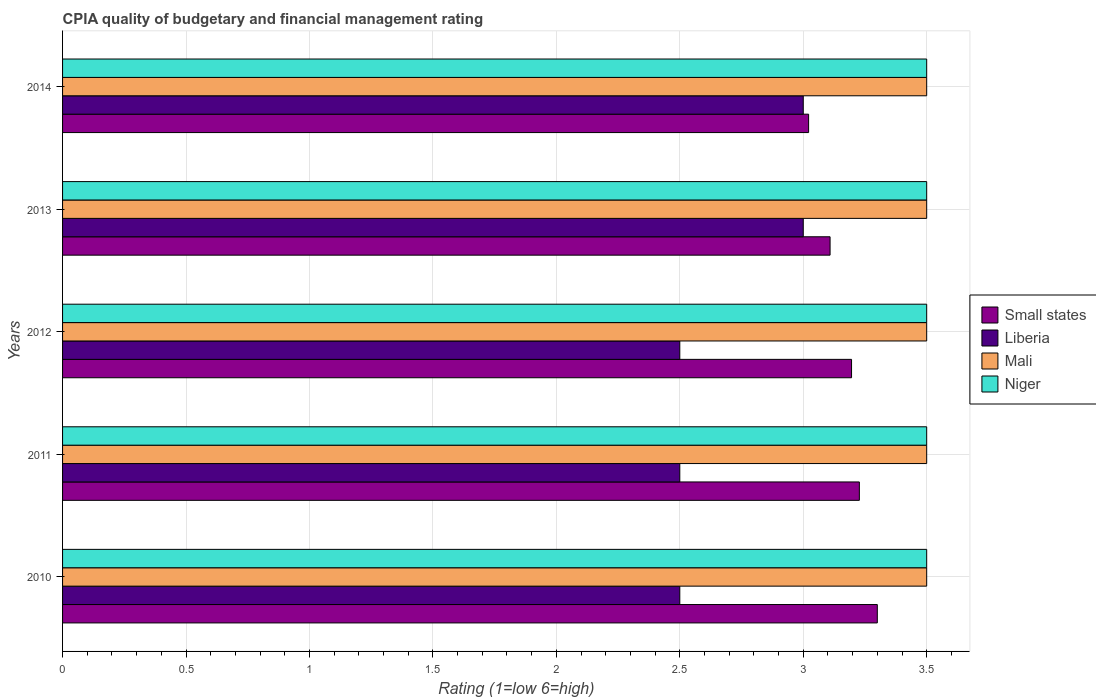Are the number of bars on each tick of the Y-axis equal?
Offer a very short reply. Yes. How many bars are there on the 2nd tick from the top?
Give a very brief answer. 4. How many bars are there on the 1st tick from the bottom?
Your answer should be very brief. 4. What is the label of the 4th group of bars from the top?
Your response must be concise. 2011. Across all years, what is the minimum CPIA rating in Mali?
Ensure brevity in your answer.  3.5. In which year was the CPIA rating in Niger minimum?
Provide a short and direct response. 2010. What is the total CPIA rating in Mali in the graph?
Keep it short and to the point. 17.5. In how many years, is the CPIA rating in Niger greater than 0.4 ?
Give a very brief answer. 5. What is the ratio of the CPIA rating in Mali in 2011 to that in 2012?
Ensure brevity in your answer.  1. Is the CPIA rating in Mali in 2010 less than that in 2012?
Provide a short and direct response. No. Is the difference between the CPIA rating in Niger in 2011 and 2014 greater than the difference between the CPIA rating in Mali in 2011 and 2014?
Offer a terse response. No. What is the difference between the highest and the second highest CPIA rating in Small states?
Make the answer very short. 0.07. Is the sum of the CPIA rating in Niger in 2011 and 2014 greater than the maximum CPIA rating in Small states across all years?
Give a very brief answer. Yes. What does the 3rd bar from the top in 2010 represents?
Provide a short and direct response. Liberia. What does the 4th bar from the bottom in 2012 represents?
Provide a succinct answer. Niger. Are all the bars in the graph horizontal?
Your response must be concise. Yes. How many years are there in the graph?
Provide a short and direct response. 5. Does the graph contain any zero values?
Ensure brevity in your answer.  No. How many legend labels are there?
Give a very brief answer. 4. What is the title of the graph?
Offer a terse response. CPIA quality of budgetary and financial management rating. Does "Channel Islands" appear as one of the legend labels in the graph?
Keep it short and to the point. No. What is the Rating (1=low 6=high) in Small states in 2010?
Your answer should be compact. 3.3. What is the Rating (1=low 6=high) in Liberia in 2010?
Provide a succinct answer. 2.5. What is the Rating (1=low 6=high) in Small states in 2011?
Your answer should be compact. 3.23. What is the Rating (1=low 6=high) in Niger in 2011?
Your response must be concise. 3.5. What is the Rating (1=low 6=high) of Small states in 2012?
Provide a succinct answer. 3.2. What is the Rating (1=low 6=high) of Liberia in 2012?
Give a very brief answer. 2.5. What is the Rating (1=low 6=high) in Mali in 2012?
Your answer should be compact. 3.5. What is the Rating (1=low 6=high) of Small states in 2013?
Provide a short and direct response. 3.11. What is the Rating (1=low 6=high) of Mali in 2013?
Give a very brief answer. 3.5. What is the Rating (1=low 6=high) of Small states in 2014?
Your answer should be very brief. 3.02. What is the Rating (1=low 6=high) of Liberia in 2014?
Your answer should be very brief. 3. What is the Rating (1=low 6=high) of Mali in 2014?
Offer a very short reply. 3.5. Across all years, what is the maximum Rating (1=low 6=high) in Small states?
Keep it short and to the point. 3.3. Across all years, what is the maximum Rating (1=low 6=high) in Liberia?
Offer a terse response. 3. Across all years, what is the maximum Rating (1=low 6=high) of Mali?
Your response must be concise. 3.5. Across all years, what is the maximum Rating (1=low 6=high) in Niger?
Keep it short and to the point. 3.5. Across all years, what is the minimum Rating (1=low 6=high) of Small states?
Keep it short and to the point. 3.02. Across all years, what is the minimum Rating (1=low 6=high) of Liberia?
Keep it short and to the point. 2.5. Across all years, what is the minimum Rating (1=low 6=high) in Mali?
Give a very brief answer. 3.5. What is the total Rating (1=low 6=high) in Small states in the graph?
Offer a terse response. 15.85. What is the total Rating (1=low 6=high) in Liberia in the graph?
Your response must be concise. 13.5. What is the total Rating (1=low 6=high) in Mali in the graph?
Your answer should be very brief. 17.5. What is the difference between the Rating (1=low 6=high) of Small states in 2010 and that in 2011?
Your response must be concise. 0.07. What is the difference between the Rating (1=low 6=high) of Small states in 2010 and that in 2012?
Make the answer very short. 0.1. What is the difference between the Rating (1=low 6=high) in Mali in 2010 and that in 2012?
Your answer should be very brief. 0. What is the difference between the Rating (1=low 6=high) in Small states in 2010 and that in 2013?
Your response must be concise. 0.19. What is the difference between the Rating (1=low 6=high) in Mali in 2010 and that in 2013?
Your response must be concise. 0. What is the difference between the Rating (1=low 6=high) in Small states in 2010 and that in 2014?
Your response must be concise. 0.28. What is the difference between the Rating (1=low 6=high) of Mali in 2010 and that in 2014?
Offer a very short reply. 0. What is the difference between the Rating (1=low 6=high) in Small states in 2011 and that in 2012?
Keep it short and to the point. 0.03. What is the difference between the Rating (1=low 6=high) in Liberia in 2011 and that in 2012?
Your answer should be compact. 0. What is the difference between the Rating (1=low 6=high) in Small states in 2011 and that in 2013?
Offer a terse response. 0.12. What is the difference between the Rating (1=low 6=high) of Liberia in 2011 and that in 2013?
Provide a succinct answer. -0.5. What is the difference between the Rating (1=low 6=high) of Niger in 2011 and that in 2013?
Offer a terse response. 0. What is the difference between the Rating (1=low 6=high) in Small states in 2011 and that in 2014?
Give a very brief answer. 0.21. What is the difference between the Rating (1=low 6=high) in Niger in 2011 and that in 2014?
Provide a succinct answer. 0. What is the difference between the Rating (1=low 6=high) of Small states in 2012 and that in 2013?
Make the answer very short. 0.09. What is the difference between the Rating (1=low 6=high) in Liberia in 2012 and that in 2013?
Provide a succinct answer. -0.5. What is the difference between the Rating (1=low 6=high) in Small states in 2012 and that in 2014?
Give a very brief answer. 0.17. What is the difference between the Rating (1=low 6=high) of Liberia in 2012 and that in 2014?
Ensure brevity in your answer.  -0.5. What is the difference between the Rating (1=low 6=high) of Small states in 2013 and that in 2014?
Make the answer very short. 0.09. What is the difference between the Rating (1=low 6=high) of Liberia in 2013 and that in 2014?
Provide a short and direct response. 0. What is the difference between the Rating (1=low 6=high) of Mali in 2013 and that in 2014?
Offer a very short reply. 0. What is the difference between the Rating (1=low 6=high) of Niger in 2013 and that in 2014?
Make the answer very short. 0. What is the difference between the Rating (1=low 6=high) of Small states in 2010 and the Rating (1=low 6=high) of Niger in 2011?
Keep it short and to the point. -0.2. What is the difference between the Rating (1=low 6=high) in Liberia in 2010 and the Rating (1=low 6=high) in Niger in 2011?
Give a very brief answer. -1. What is the difference between the Rating (1=low 6=high) of Small states in 2010 and the Rating (1=low 6=high) of Liberia in 2012?
Your response must be concise. 0.8. What is the difference between the Rating (1=low 6=high) of Liberia in 2010 and the Rating (1=low 6=high) of Mali in 2012?
Give a very brief answer. -1. What is the difference between the Rating (1=low 6=high) in Liberia in 2010 and the Rating (1=low 6=high) in Niger in 2012?
Your answer should be very brief. -1. What is the difference between the Rating (1=low 6=high) of Small states in 2010 and the Rating (1=low 6=high) of Liberia in 2013?
Keep it short and to the point. 0.3. What is the difference between the Rating (1=low 6=high) in Liberia in 2010 and the Rating (1=low 6=high) in Niger in 2013?
Provide a succinct answer. -1. What is the difference between the Rating (1=low 6=high) in Mali in 2010 and the Rating (1=low 6=high) in Niger in 2013?
Offer a very short reply. 0. What is the difference between the Rating (1=low 6=high) in Small states in 2010 and the Rating (1=low 6=high) in Niger in 2014?
Provide a succinct answer. -0.2. What is the difference between the Rating (1=low 6=high) in Liberia in 2010 and the Rating (1=low 6=high) in Niger in 2014?
Keep it short and to the point. -1. What is the difference between the Rating (1=low 6=high) of Small states in 2011 and the Rating (1=low 6=high) of Liberia in 2012?
Your answer should be compact. 0.73. What is the difference between the Rating (1=low 6=high) in Small states in 2011 and the Rating (1=low 6=high) in Mali in 2012?
Offer a terse response. -0.27. What is the difference between the Rating (1=low 6=high) in Small states in 2011 and the Rating (1=low 6=high) in Niger in 2012?
Keep it short and to the point. -0.27. What is the difference between the Rating (1=low 6=high) of Liberia in 2011 and the Rating (1=low 6=high) of Niger in 2012?
Ensure brevity in your answer.  -1. What is the difference between the Rating (1=low 6=high) in Mali in 2011 and the Rating (1=low 6=high) in Niger in 2012?
Provide a short and direct response. 0. What is the difference between the Rating (1=low 6=high) in Small states in 2011 and the Rating (1=low 6=high) in Liberia in 2013?
Provide a short and direct response. 0.23. What is the difference between the Rating (1=low 6=high) in Small states in 2011 and the Rating (1=low 6=high) in Mali in 2013?
Offer a very short reply. -0.27. What is the difference between the Rating (1=low 6=high) of Small states in 2011 and the Rating (1=low 6=high) of Niger in 2013?
Provide a succinct answer. -0.27. What is the difference between the Rating (1=low 6=high) of Liberia in 2011 and the Rating (1=low 6=high) of Mali in 2013?
Provide a succinct answer. -1. What is the difference between the Rating (1=low 6=high) in Small states in 2011 and the Rating (1=low 6=high) in Liberia in 2014?
Your response must be concise. 0.23. What is the difference between the Rating (1=low 6=high) of Small states in 2011 and the Rating (1=low 6=high) of Mali in 2014?
Give a very brief answer. -0.27. What is the difference between the Rating (1=low 6=high) of Small states in 2011 and the Rating (1=low 6=high) of Niger in 2014?
Your answer should be very brief. -0.27. What is the difference between the Rating (1=low 6=high) in Liberia in 2011 and the Rating (1=low 6=high) in Niger in 2014?
Keep it short and to the point. -1. What is the difference between the Rating (1=low 6=high) of Mali in 2011 and the Rating (1=low 6=high) of Niger in 2014?
Give a very brief answer. 0. What is the difference between the Rating (1=low 6=high) of Small states in 2012 and the Rating (1=low 6=high) of Liberia in 2013?
Make the answer very short. 0.2. What is the difference between the Rating (1=low 6=high) of Small states in 2012 and the Rating (1=low 6=high) of Mali in 2013?
Give a very brief answer. -0.3. What is the difference between the Rating (1=low 6=high) in Small states in 2012 and the Rating (1=low 6=high) in Niger in 2013?
Your answer should be compact. -0.3. What is the difference between the Rating (1=low 6=high) of Liberia in 2012 and the Rating (1=low 6=high) of Niger in 2013?
Provide a short and direct response. -1. What is the difference between the Rating (1=low 6=high) in Small states in 2012 and the Rating (1=low 6=high) in Liberia in 2014?
Make the answer very short. 0.2. What is the difference between the Rating (1=low 6=high) of Small states in 2012 and the Rating (1=low 6=high) of Mali in 2014?
Offer a very short reply. -0.3. What is the difference between the Rating (1=low 6=high) of Small states in 2012 and the Rating (1=low 6=high) of Niger in 2014?
Your answer should be very brief. -0.3. What is the difference between the Rating (1=low 6=high) in Liberia in 2012 and the Rating (1=low 6=high) in Niger in 2014?
Your response must be concise. -1. What is the difference between the Rating (1=low 6=high) in Mali in 2012 and the Rating (1=low 6=high) in Niger in 2014?
Your response must be concise. 0. What is the difference between the Rating (1=low 6=high) in Small states in 2013 and the Rating (1=low 6=high) in Liberia in 2014?
Offer a terse response. 0.11. What is the difference between the Rating (1=low 6=high) in Small states in 2013 and the Rating (1=low 6=high) in Mali in 2014?
Provide a succinct answer. -0.39. What is the difference between the Rating (1=low 6=high) in Small states in 2013 and the Rating (1=low 6=high) in Niger in 2014?
Keep it short and to the point. -0.39. What is the difference between the Rating (1=low 6=high) in Mali in 2013 and the Rating (1=low 6=high) in Niger in 2014?
Offer a terse response. 0. What is the average Rating (1=low 6=high) in Small states per year?
Make the answer very short. 3.17. What is the average Rating (1=low 6=high) in Liberia per year?
Offer a terse response. 2.7. What is the average Rating (1=low 6=high) in Mali per year?
Provide a succinct answer. 3.5. What is the average Rating (1=low 6=high) of Niger per year?
Offer a very short reply. 3.5. In the year 2010, what is the difference between the Rating (1=low 6=high) in Small states and Rating (1=low 6=high) in Niger?
Give a very brief answer. -0.2. In the year 2011, what is the difference between the Rating (1=low 6=high) in Small states and Rating (1=low 6=high) in Liberia?
Make the answer very short. 0.73. In the year 2011, what is the difference between the Rating (1=low 6=high) of Small states and Rating (1=low 6=high) of Mali?
Your response must be concise. -0.27. In the year 2011, what is the difference between the Rating (1=low 6=high) in Small states and Rating (1=low 6=high) in Niger?
Provide a short and direct response. -0.27. In the year 2012, what is the difference between the Rating (1=low 6=high) in Small states and Rating (1=low 6=high) in Liberia?
Keep it short and to the point. 0.7. In the year 2012, what is the difference between the Rating (1=low 6=high) of Small states and Rating (1=low 6=high) of Mali?
Offer a terse response. -0.3. In the year 2012, what is the difference between the Rating (1=low 6=high) of Small states and Rating (1=low 6=high) of Niger?
Keep it short and to the point. -0.3. In the year 2012, what is the difference between the Rating (1=low 6=high) in Mali and Rating (1=low 6=high) in Niger?
Offer a very short reply. 0. In the year 2013, what is the difference between the Rating (1=low 6=high) in Small states and Rating (1=low 6=high) in Liberia?
Provide a short and direct response. 0.11. In the year 2013, what is the difference between the Rating (1=low 6=high) in Small states and Rating (1=low 6=high) in Mali?
Ensure brevity in your answer.  -0.39. In the year 2013, what is the difference between the Rating (1=low 6=high) of Small states and Rating (1=low 6=high) of Niger?
Your answer should be very brief. -0.39. In the year 2013, what is the difference between the Rating (1=low 6=high) in Liberia and Rating (1=low 6=high) in Niger?
Provide a succinct answer. -0.5. In the year 2014, what is the difference between the Rating (1=low 6=high) of Small states and Rating (1=low 6=high) of Liberia?
Provide a succinct answer. 0.02. In the year 2014, what is the difference between the Rating (1=low 6=high) of Small states and Rating (1=low 6=high) of Mali?
Ensure brevity in your answer.  -0.48. In the year 2014, what is the difference between the Rating (1=low 6=high) of Small states and Rating (1=low 6=high) of Niger?
Make the answer very short. -0.48. In the year 2014, what is the difference between the Rating (1=low 6=high) of Liberia and Rating (1=low 6=high) of Mali?
Offer a terse response. -0.5. In the year 2014, what is the difference between the Rating (1=low 6=high) in Liberia and Rating (1=low 6=high) in Niger?
Give a very brief answer. -0.5. In the year 2014, what is the difference between the Rating (1=low 6=high) of Mali and Rating (1=low 6=high) of Niger?
Give a very brief answer. 0. What is the ratio of the Rating (1=low 6=high) in Small states in 2010 to that in 2011?
Offer a very short reply. 1.02. What is the ratio of the Rating (1=low 6=high) in Niger in 2010 to that in 2011?
Provide a succinct answer. 1. What is the ratio of the Rating (1=low 6=high) of Small states in 2010 to that in 2012?
Offer a terse response. 1.03. What is the ratio of the Rating (1=low 6=high) of Small states in 2010 to that in 2013?
Give a very brief answer. 1.06. What is the ratio of the Rating (1=low 6=high) in Mali in 2010 to that in 2013?
Your answer should be compact. 1. What is the ratio of the Rating (1=low 6=high) of Niger in 2010 to that in 2013?
Provide a succinct answer. 1. What is the ratio of the Rating (1=low 6=high) of Small states in 2010 to that in 2014?
Your answer should be compact. 1.09. What is the ratio of the Rating (1=low 6=high) of Small states in 2011 to that in 2012?
Keep it short and to the point. 1.01. What is the ratio of the Rating (1=low 6=high) in Niger in 2011 to that in 2012?
Your answer should be compact. 1. What is the ratio of the Rating (1=low 6=high) in Small states in 2011 to that in 2013?
Your response must be concise. 1.04. What is the ratio of the Rating (1=low 6=high) in Liberia in 2011 to that in 2013?
Provide a short and direct response. 0.83. What is the ratio of the Rating (1=low 6=high) of Niger in 2011 to that in 2013?
Your response must be concise. 1. What is the ratio of the Rating (1=low 6=high) in Small states in 2011 to that in 2014?
Your response must be concise. 1.07. What is the ratio of the Rating (1=low 6=high) of Liberia in 2011 to that in 2014?
Make the answer very short. 0.83. What is the ratio of the Rating (1=low 6=high) of Niger in 2011 to that in 2014?
Your response must be concise. 1. What is the ratio of the Rating (1=low 6=high) of Small states in 2012 to that in 2013?
Your answer should be compact. 1.03. What is the ratio of the Rating (1=low 6=high) of Small states in 2012 to that in 2014?
Your answer should be compact. 1.06. What is the ratio of the Rating (1=low 6=high) of Small states in 2013 to that in 2014?
Your answer should be compact. 1.03. What is the ratio of the Rating (1=low 6=high) of Liberia in 2013 to that in 2014?
Make the answer very short. 1. What is the ratio of the Rating (1=low 6=high) in Niger in 2013 to that in 2014?
Your response must be concise. 1. What is the difference between the highest and the second highest Rating (1=low 6=high) of Small states?
Offer a terse response. 0.07. What is the difference between the highest and the second highest Rating (1=low 6=high) in Mali?
Your answer should be very brief. 0. What is the difference between the highest and the second highest Rating (1=low 6=high) of Niger?
Offer a very short reply. 0. What is the difference between the highest and the lowest Rating (1=low 6=high) in Small states?
Give a very brief answer. 0.28. 